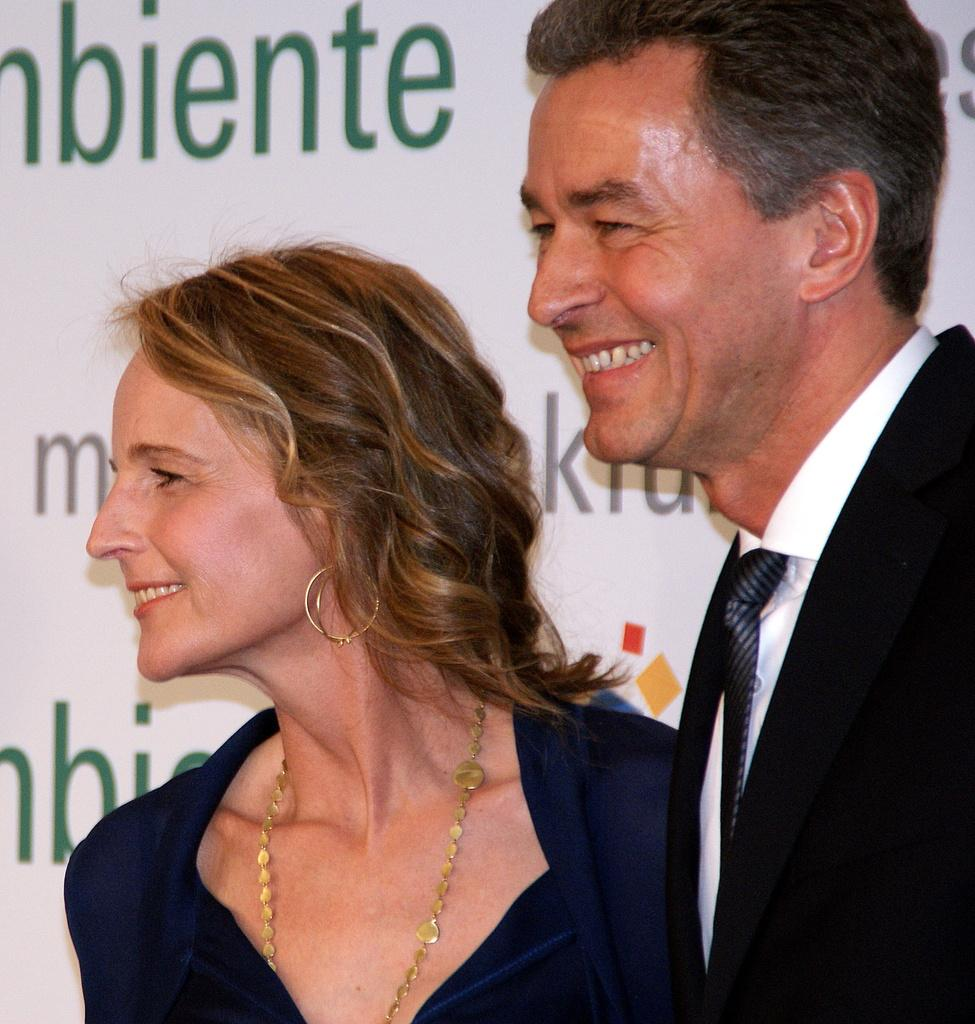How many people are present in the image? There are two persons in the image. What can be seen on a wall in the image? There is a text on a wall in the image. Can you describe the setting where the image might have been taken? The image may have been taken in a hall. What type of fan is visible in the image? There is no fan present in the image. What type of star can be seen in the image? There is no star present in the image. 